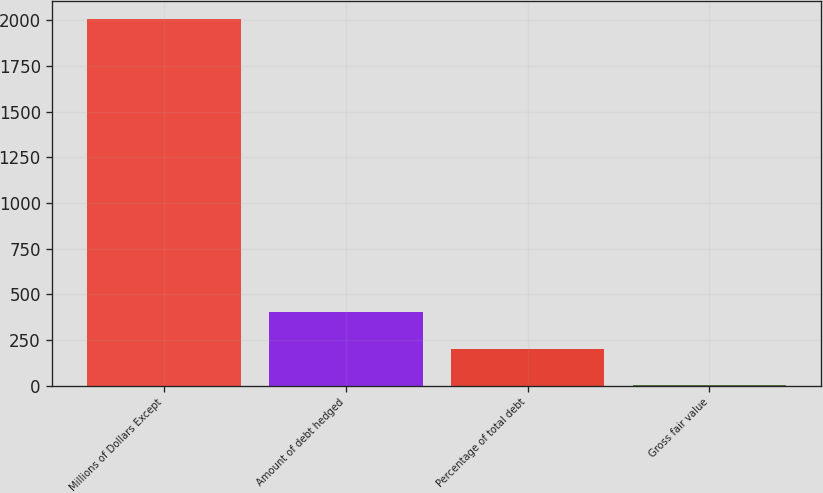Convert chart. <chart><loc_0><loc_0><loc_500><loc_500><bar_chart><fcel>Millions of Dollars Except<fcel>Amount of debt hedged<fcel>Percentage of total debt<fcel>Gross fair value<nl><fcel>2007<fcel>403<fcel>202.5<fcel>2<nl></chart> 